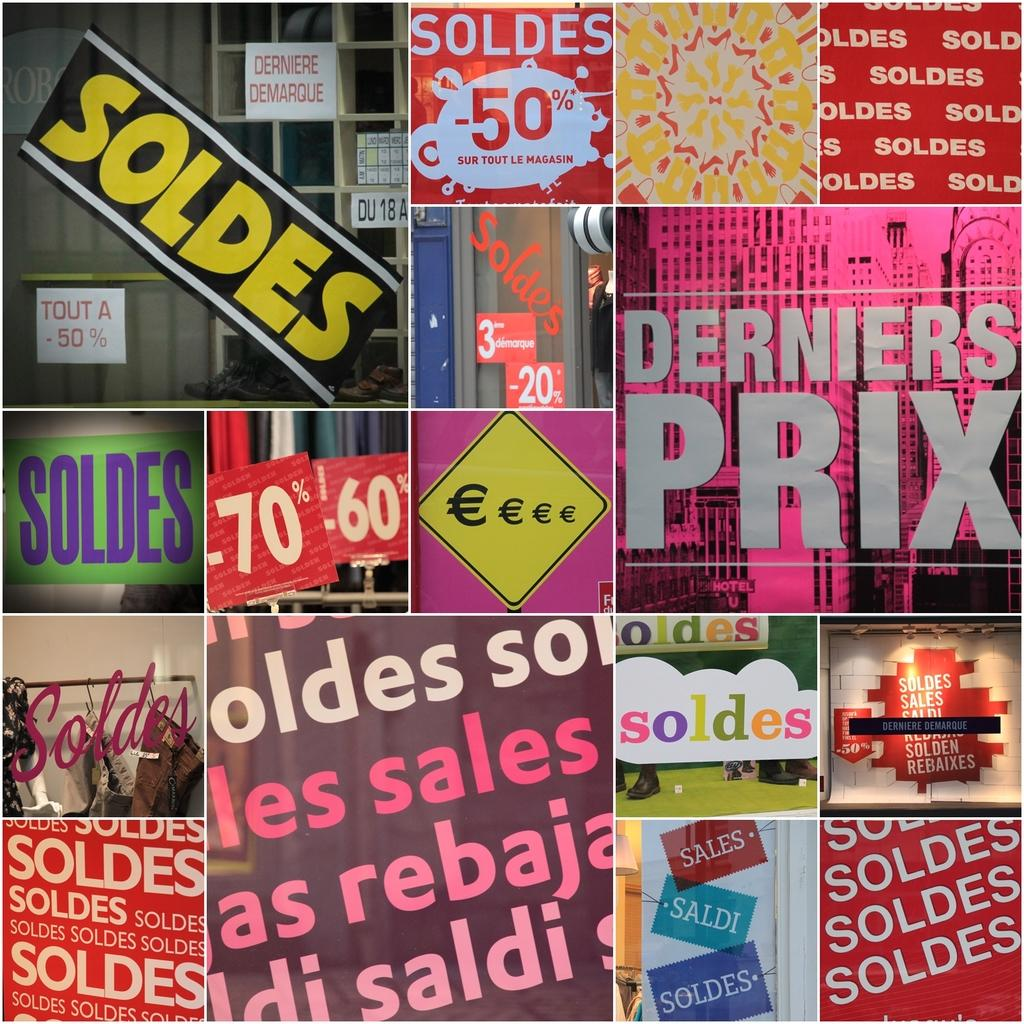Provide a one-sentence caption for the provided image. a surface with derniers prix written on it. 